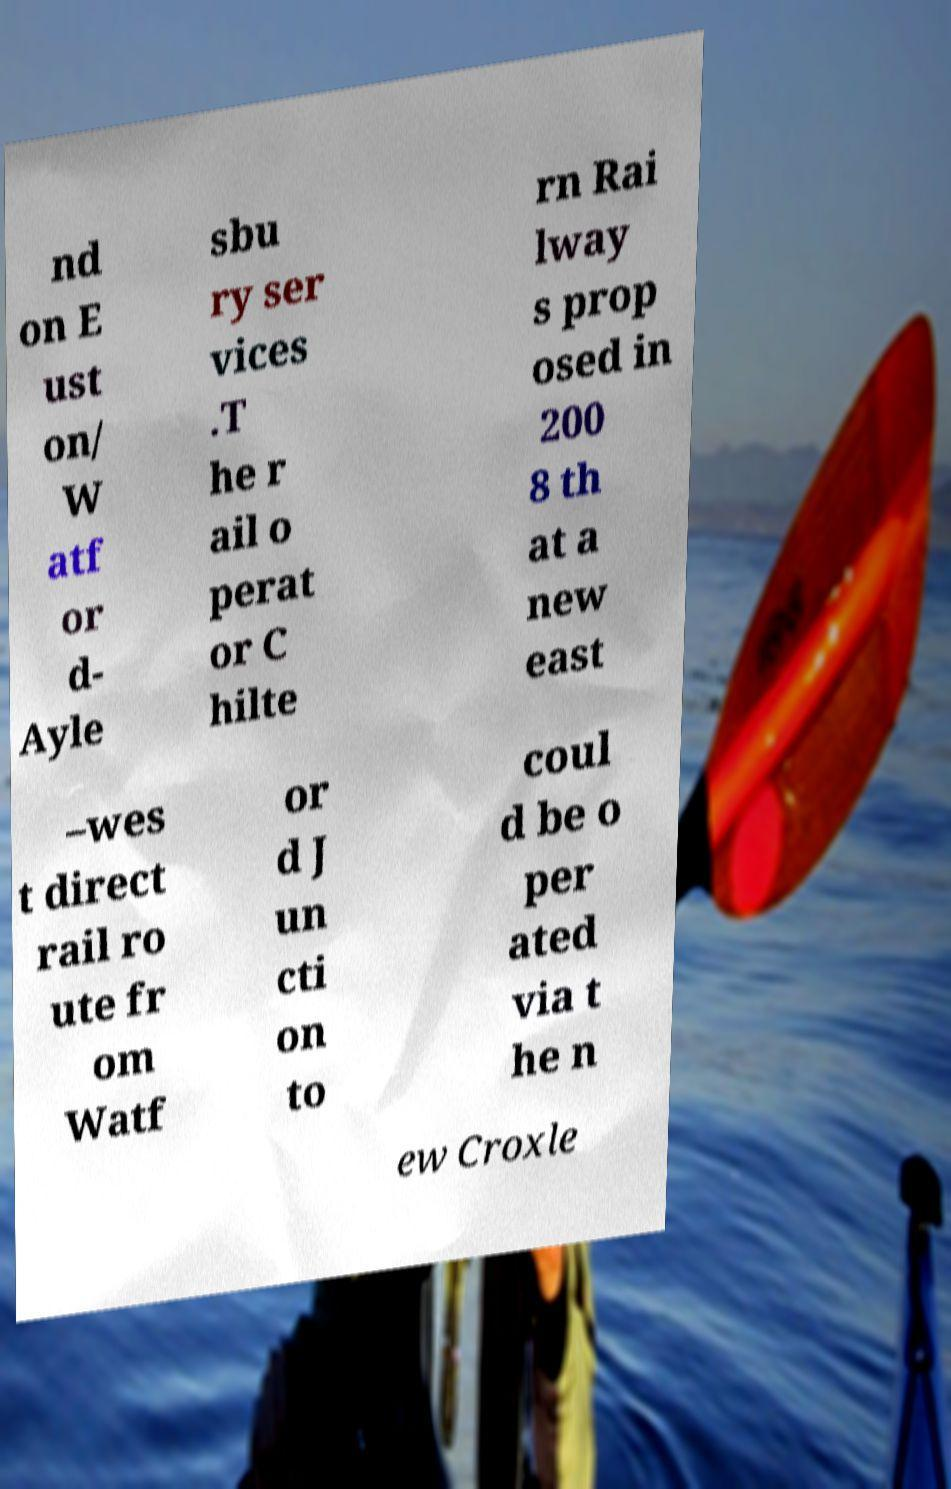Please read and relay the text visible in this image. What does it say? nd on E ust on/ W atf or d- Ayle sbu ry ser vices .T he r ail o perat or C hilte rn Rai lway s prop osed in 200 8 th at a new east –wes t direct rail ro ute fr om Watf or d J un cti on to coul d be o per ated via t he n ew Croxle 